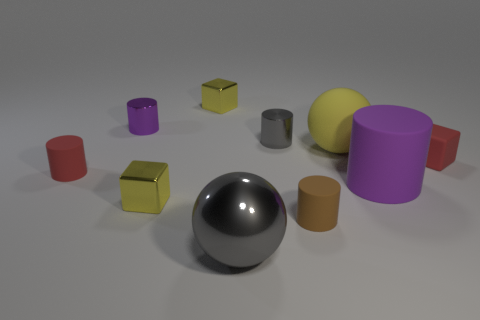There is a small metal cylinder that is on the right side of the yellow cube behind the red rubber thing right of the red rubber cylinder; what color is it?
Your answer should be compact. Gray. Does the large cylinder have the same material as the tiny yellow cube that is in front of the red cylinder?
Ensure brevity in your answer.  No. There is a brown matte object that is the same shape as the large purple thing; what size is it?
Keep it short and to the point. Small. Are there the same number of big purple rubber cylinders that are to the right of the small brown matte cylinder and brown rubber cylinders left of the small purple cylinder?
Give a very brief answer. No. How many other things are there of the same material as the big purple cylinder?
Make the answer very short. 4. Are there an equal number of brown rubber objects that are right of the red block and tiny red matte cubes?
Ensure brevity in your answer.  No. Does the purple matte object have the same size as the block on the right side of the brown cylinder?
Your response must be concise. No. The large thing that is behind the red matte cube has what shape?
Your answer should be very brief. Sphere. Is there any other thing that has the same shape as the large shiny thing?
Provide a succinct answer. Yes. Is there a small cyan matte cylinder?
Give a very brief answer. No. 